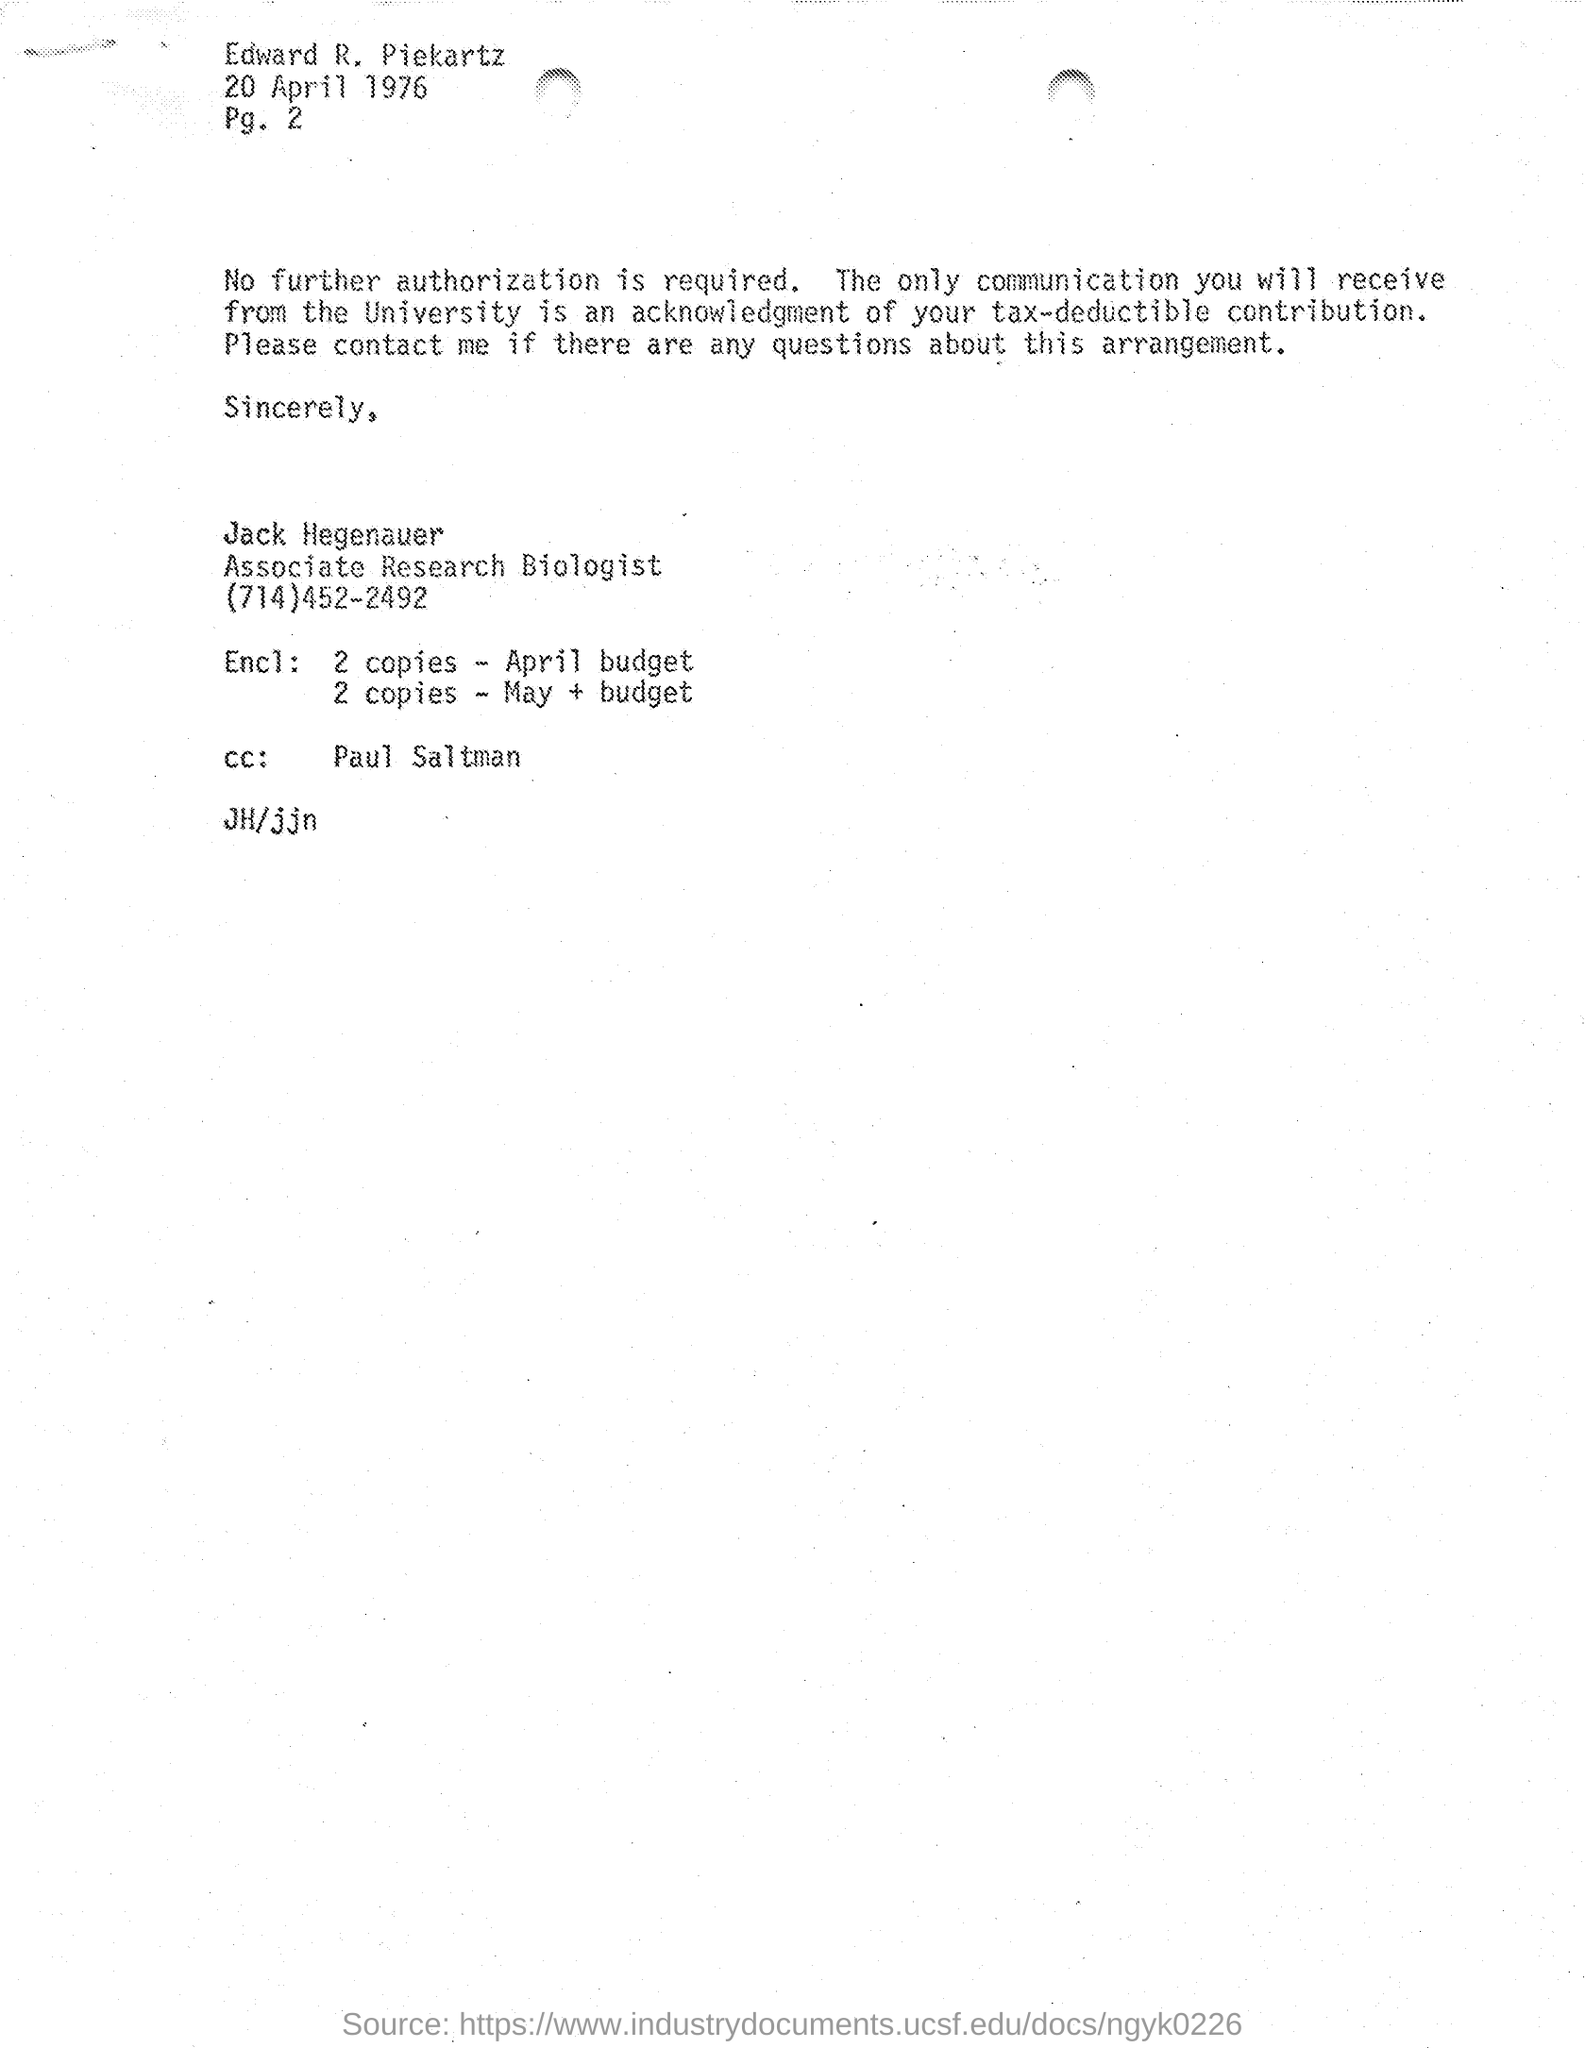Identify some key points in this picture. The CC is sent to Paul Saltman. The author of the letter is Jack Hegenauer. 